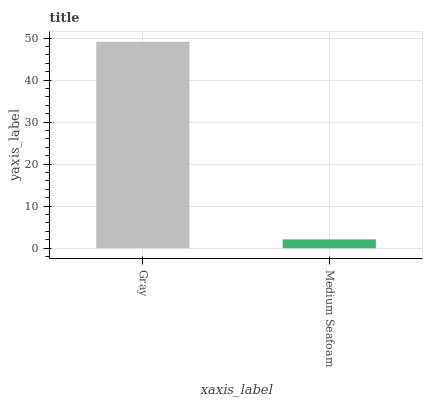Is Medium Seafoam the minimum?
Answer yes or no. Yes. Is Gray the maximum?
Answer yes or no. Yes. Is Medium Seafoam the maximum?
Answer yes or no. No. Is Gray greater than Medium Seafoam?
Answer yes or no. Yes. Is Medium Seafoam less than Gray?
Answer yes or no. Yes. Is Medium Seafoam greater than Gray?
Answer yes or no. No. Is Gray less than Medium Seafoam?
Answer yes or no. No. Is Gray the high median?
Answer yes or no. Yes. Is Medium Seafoam the low median?
Answer yes or no. Yes. Is Medium Seafoam the high median?
Answer yes or no. No. Is Gray the low median?
Answer yes or no. No. 